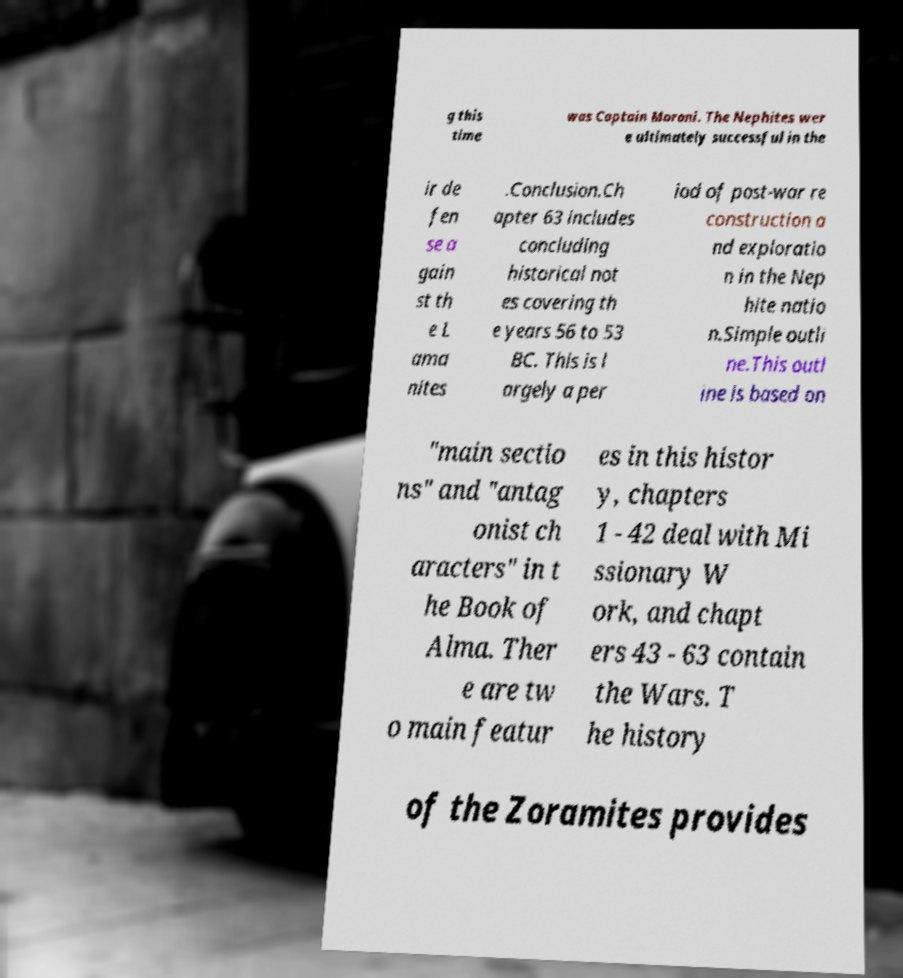Can you read and provide the text displayed in the image?This photo seems to have some interesting text. Can you extract and type it out for me? g this time was Captain Moroni. The Nephites wer e ultimately successful in the ir de fen se a gain st th e L ama nites .Conclusion.Ch apter 63 includes concluding historical not es covering th e years 56 to 53 BC. This is l argely a per iod of post-war re construction a nd exploratio n in the Nep hite natio n.Simple outli ne.This outl ine is based on "main sectio ns" and "antag onist ch aracters" in t he Book of Alma. Ther e are tw o main featur es in this histor y, chapters 1 - 42 deal with Mi ssionary W ork, and chapt ers 43 - 63 contain the Wars. T he history of the Zoramites provides 